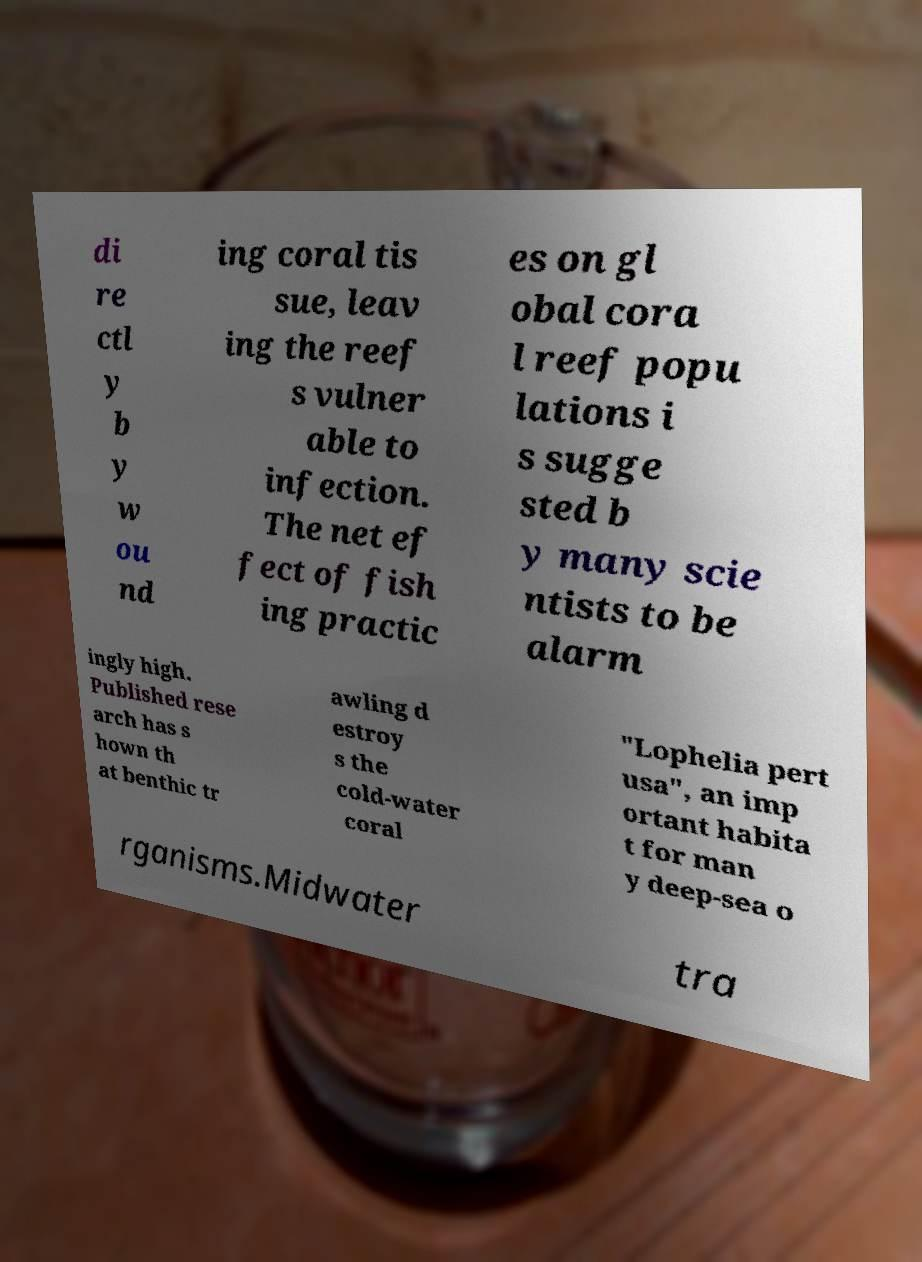Could you extract and type out the text from this image? di re ctl y b y w ou nd ing coral tis sue, leav ing the reef s vulner able to infection. The net ef fect of fish ing practic es on gl obal cora l reef popu lations i s sugge sted b y many scie ntists to be alarm ingly high. Published rese arch has s hown th at benthic tr awling d estroy s the cold-water coral "Lophelia pert usa", an imp ortant habita t for man y deep-sea o rganisms.Midwater tra 